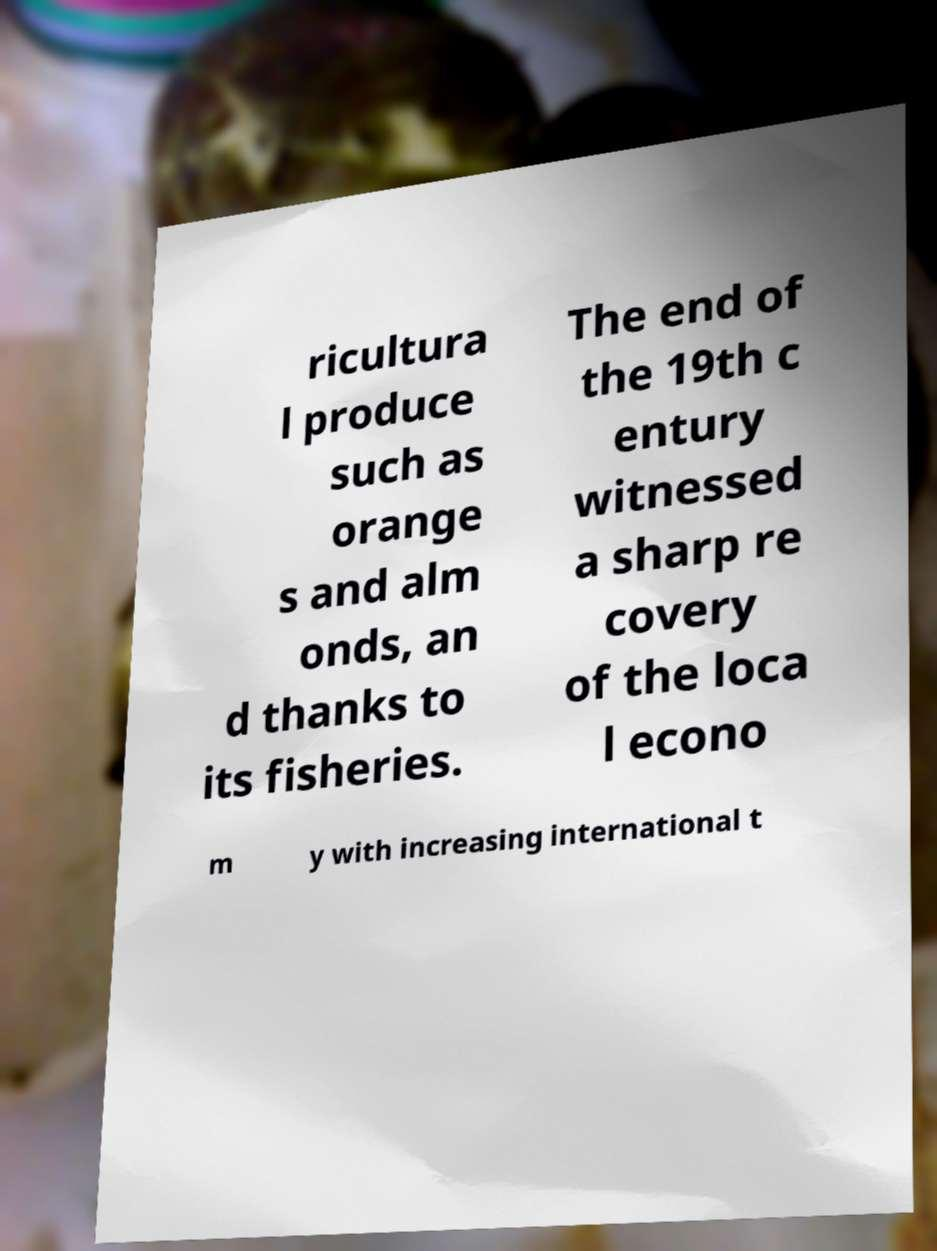I need the written content from this picture converted into text. Can you do that? ricultura l produce such as orange s and alm onds, an d thanks to its fisheries. The end of the 19th c entury witnessed a sharp re covery of the loca l econo m y with increasing international t 